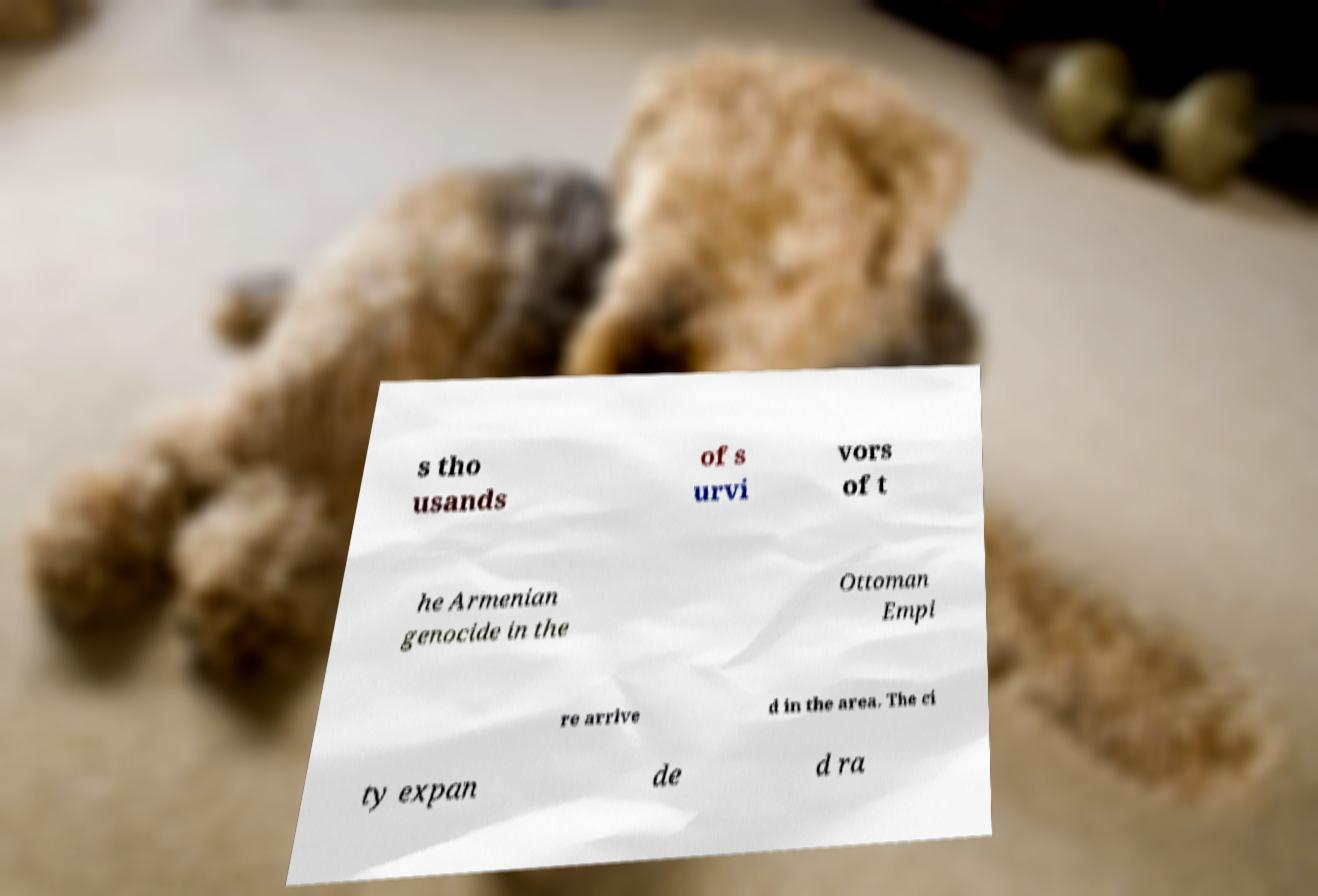What messages or text are displayed in this image? I need them in a readable, typed format. s tho usands of s urvi vors of t he Armenian genocide in the Ottoman Empi re arrive d in the area. The ci ty expan de d ra 